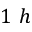Convert formula to latex. <formula><loc_0><loc_0><loc_500><loc_500>1 h</formula> 